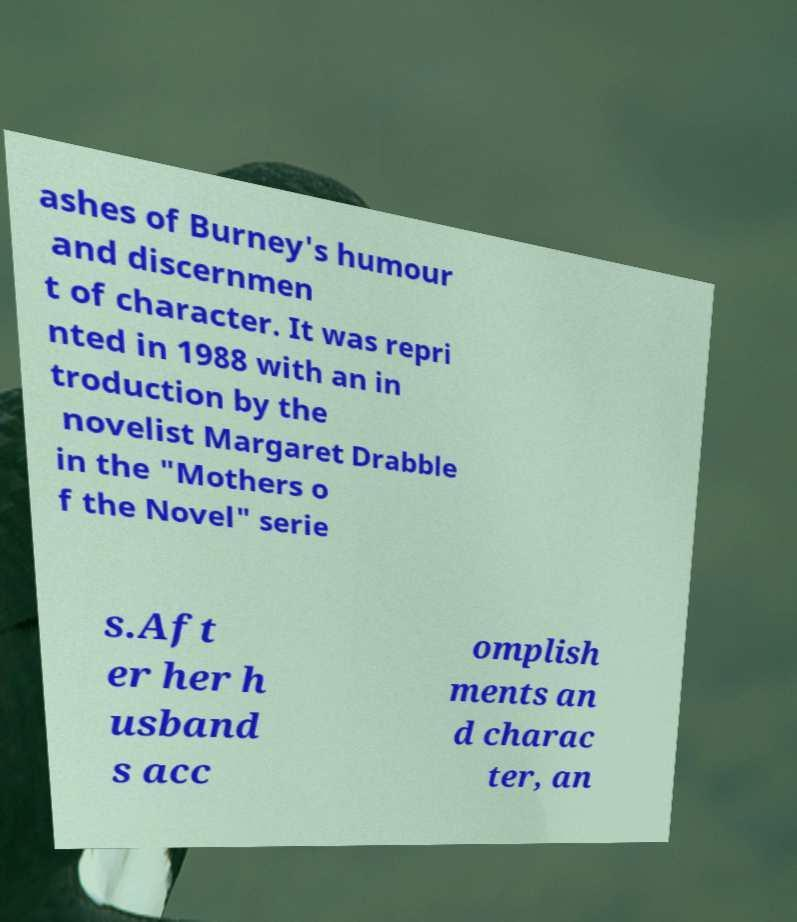Can you accurately transcribe the text from the provided image for me? ashes of Burney's humour and discernmen t of character. It was repri nted in 1988 with an in troduction by the novelist Margaret Drabble in the "Mothers o f the Novel" serie s.Aft er her h usband s acc omplish ments an d charac ter, an 